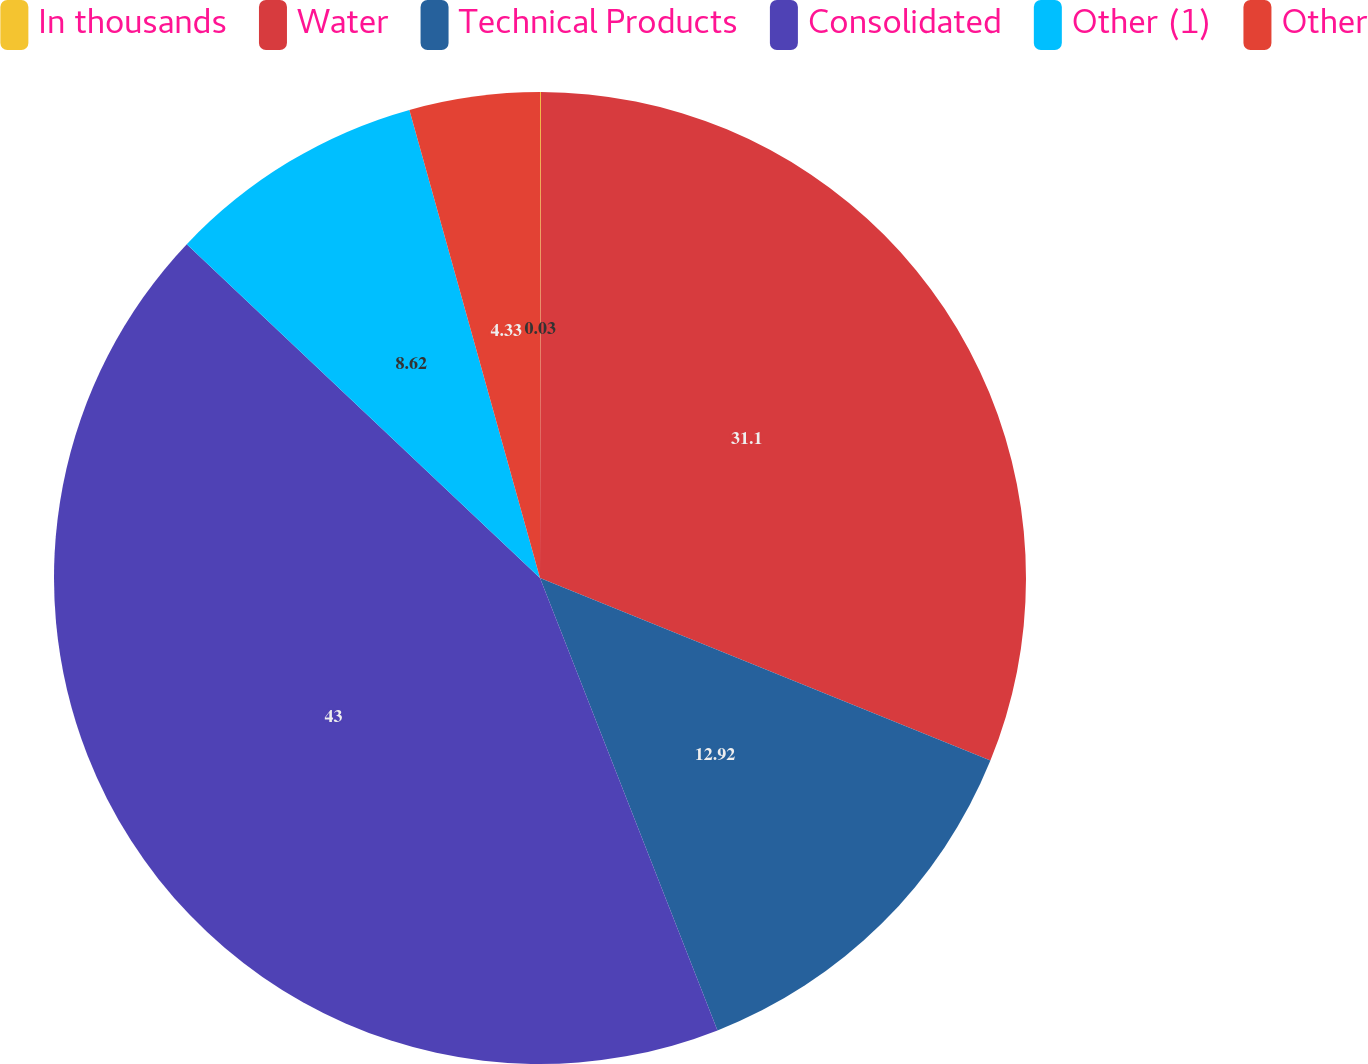<chart> <loc_0><loc_0><loc_500><loc_500><pie_chart><fcel>In thousands<fcel>Water<fcel>Technical Products<fcel>Consolidated<fcel>Other (1)<fcel>Other<nl><fcel>0.03%<fcel>31.1%<fcel>12.92%<fcel>43.0%<fcel>8.62%<fcel>4.33%<nl></chart> 